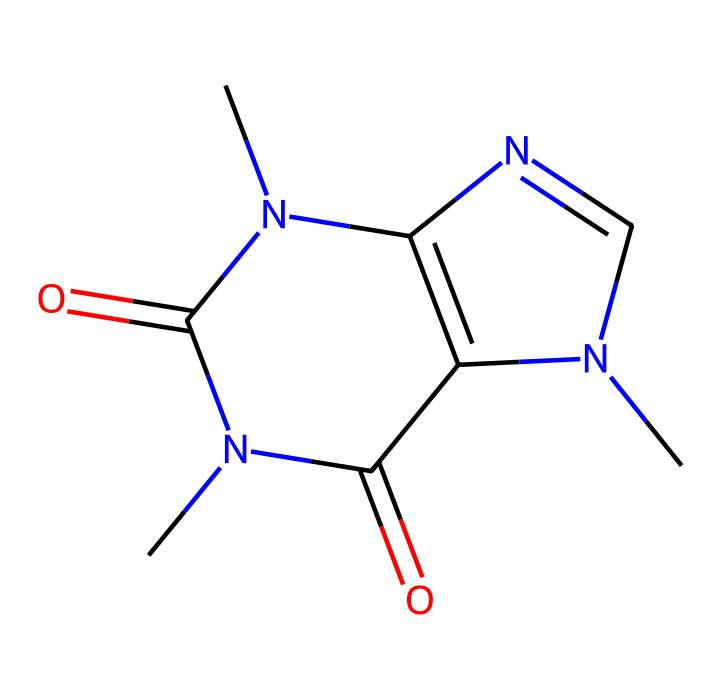How many nitrogen atoms are present in the structure? By examining the provided SMILES representation, we can identify that there are two instances of 'N', indicating two nitrogen atoms.
Answer: two What is the molecular formula of caffeine? Analyzing the structure represents twelve carbon atoms (C), fifteen hydrogen atoms (H), and six nitrogen atoms (N), leading to the molecular formula C8H10N4O2.
Answer: C8H10N4O2 How many rings are present in the caffeine structure? The SMILES representation indicates that there are two fused rings, as denoted by the 'N1' and 'C2', indicating connectivity and fusion.
Answer: two What functional groups are present in caffeine? The structure features carbonyl (C=O) groups indicated in the representation, which forms part of the amide group connections (–C(=O)N–) in the molecule.
Answer: carbonyl Which two elements are the predominant heteroatoms in caffeine? Looking at the structure, the heteroatoms that differ from carbon and hydrogen are nitrogen (N) and oxygen (O), which are clear from the presence of 'N' and 'O' in the SMILES notation.
Answer: nitrogen and oxygen What kind of activity does caffeine primarily exhibit in the human body? Caffeine acts mainly as a stimulant and its structure contributes to its ability to block adenosine receptors, affecting central nervous system activity.
Answer: stimulant What category of compounds does caffeine belong to? Given the presence of nitrogen atoms in its structure, caffeine is categorized specifically as an alkaloid, which contains basic nitrogen atoms and exhibits physiological effects.
Answer: alkaloid 